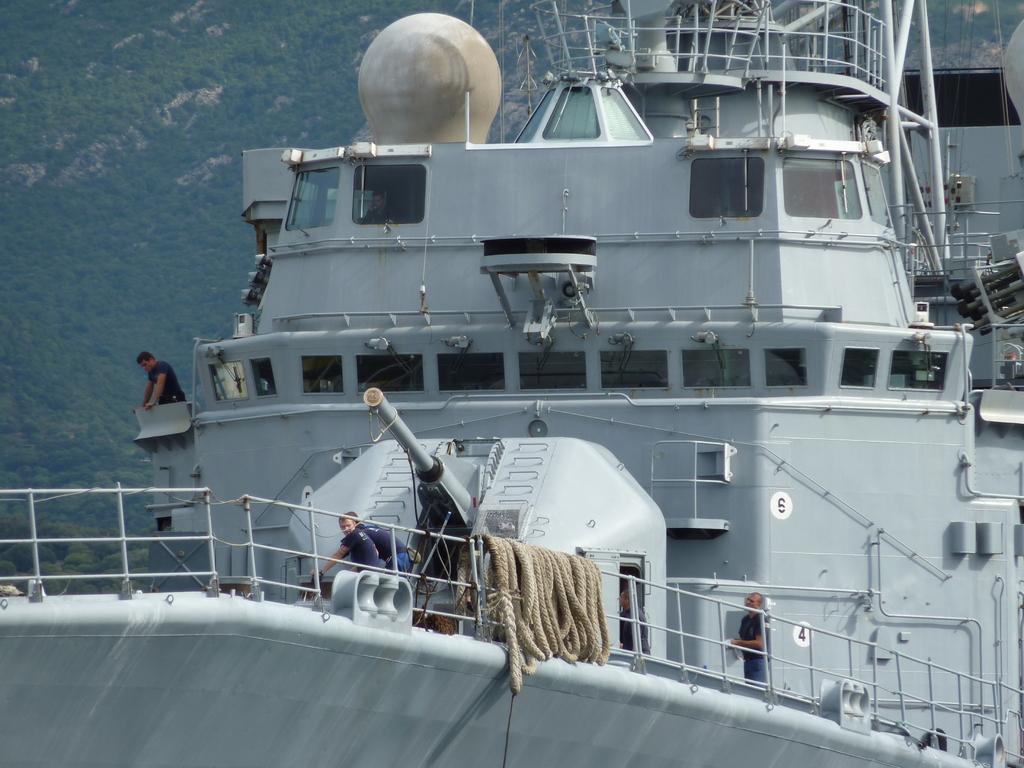In one or two sentences, can you explain what this image depicts? In this image I can see a ship in the front and on it I can see few people. I can also see brown colour ropes and railings in the front. On the top right side of this image I can see few wires and on the left side of this image I can see trees. 